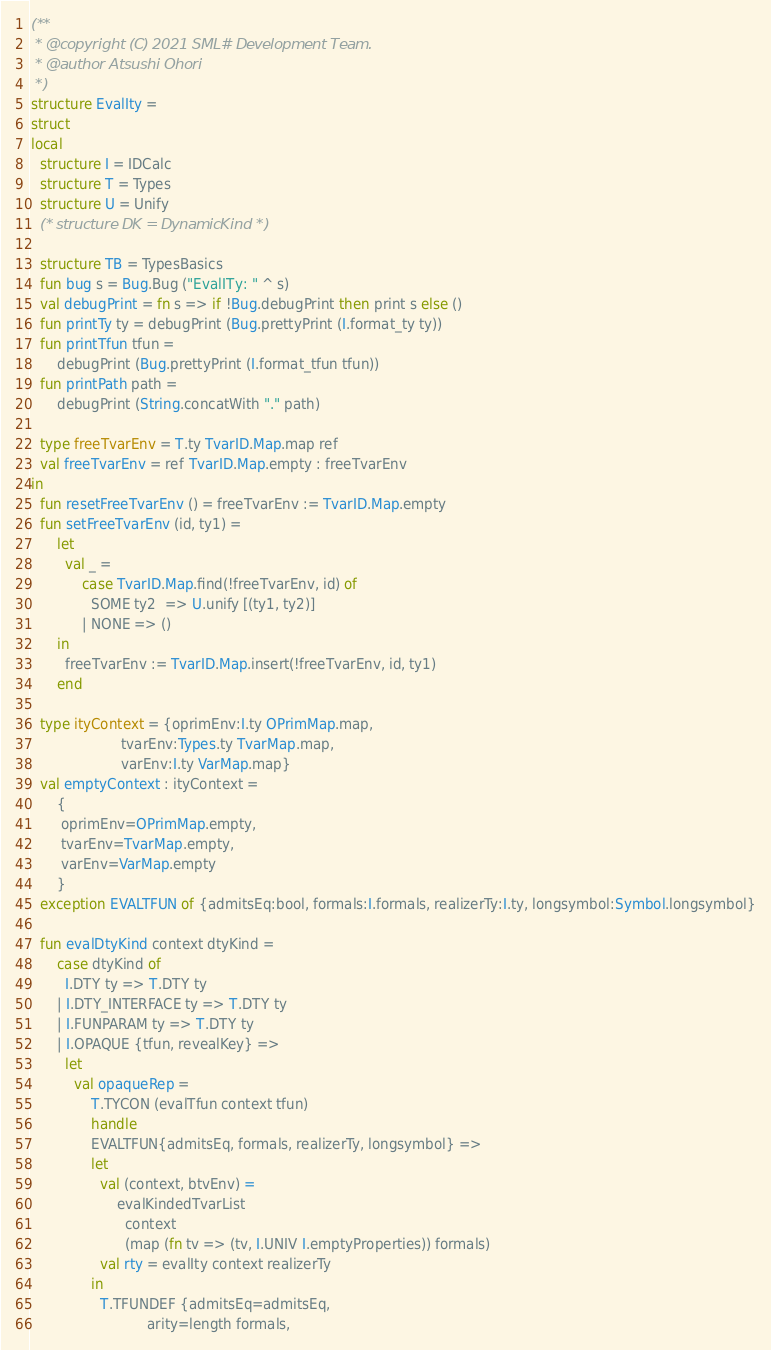Convert code to text. <code><loc_0><loc_0><loc_500><loc_500><_SML_>(**
 * @copyright (C) 2021 SML# Development Team.
 * @author Atsushi Ohori
 *)
structure EvalIty =
struct
local
  structure I = IDCalc
  structure T = Types
  structure U = Unify
  (* structure DK = DynamicKind *)

  structure TB = TypesBasics
  fun bug s = Bug.Bug ("EvalITy: " ^ s)
  val debugPrint = fn s => if !Bug.debugPrint then print s else ()
  fun printTy ty = debugPrint (Bug.prettyPrint (I.format_ty ty))
  fun printTfun tfun =
      debugPrint (Bug.prettyPrint (I.format_tfun tfun))
  fun printPath path =
      debugPrint (String.concatWith "." path)

  type freeTvarEnv = T.ty TvarID.Map.map ref
  val freeTvarEnv = ref TvarID.Map.empty : freeTvarEnv
in
  fun resetFreeTvarEnv () = freeTvarEnv := TvarID.Map.empty
  fun setFreeTvarEnv (id, ty1) = 
      let
        val _ = 
            case TvarID.Map.find(!freeTvarEnv, id) of
              SOME ty2  => U.unify [(ty1, ty2)]
            | NONE => ()
      in
        freeTvarEnv := TvarID.Map.insert(!freeTvarEnv, id, ty1)
      end
      
  type ityContext = {oprimEnv:I.ty OPrimMap.map,
                     tvarEnv:Types.ty TvarMap.map, 
                     varEnv:I.ty VarMap.map}
  val emptyContext : ityContext = 
      {
       oprimEnv=OPrimMap.empty,
       tvarEnv=TvarMap.empty,
       varEnv=VarMap.empty
      }
  exception EVALTFUN of {admitsEq:bool, formals:I.formals, realizerTy:I.ty, longsymbol:Symbol.longsymbol}

  fun evalDtyKind context dtyKind = 
      case dtyKind of
        I.DTY ty => T.DTY ty
      | I.DTY_INTERFACE ty => T.DTY ty
      | I.FUNPARAM ty => T.DTY ty
      | I.OPAQUE {tfun, revealKey} =>
        let
          val opaqueRep = 
              T.TYCON (evalTfun context tfun)
              handle
              EVALTFUN{admitsEq, formals, realizerTy, longsymbol} =>
              let
                val (context, btvEnv) =
                    evalKindedTvarList
                      context 
                      (map (fn tv => (tv, I.UNIV I.emptyProperties)) formals)
                val rty = evalIty context realizerTy
              in
                T.TFUNDEF {admitsEq=admitsEq,
                           arity=length formals,</code> 